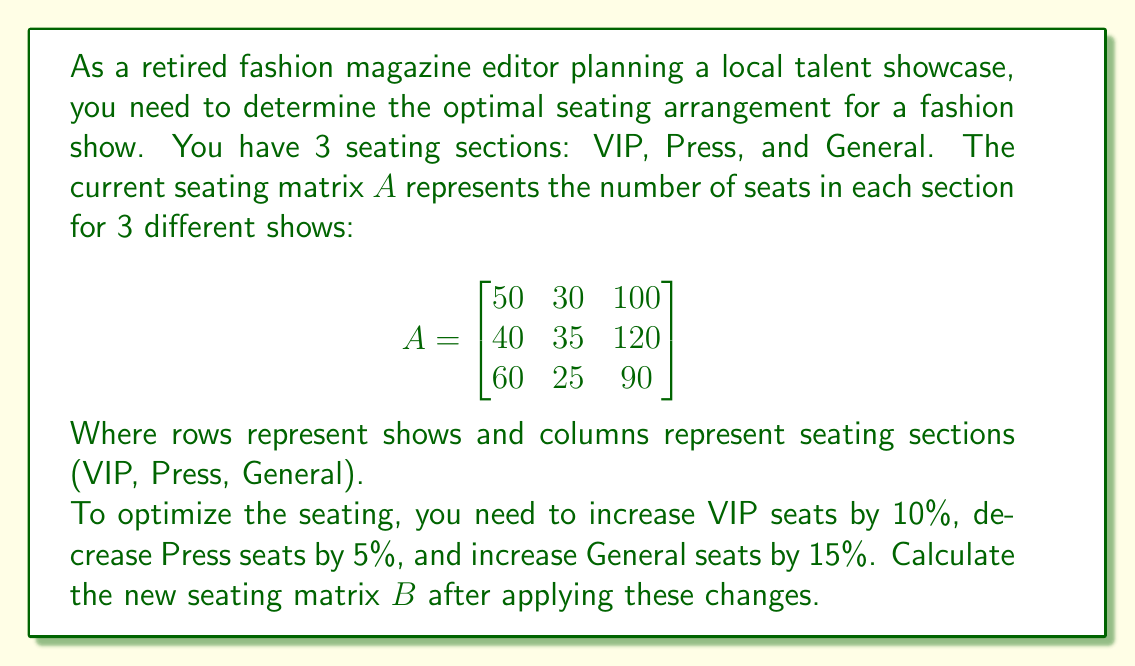Solve this math problem. To solve this problem, we need to apply the given percentage changes to each section of seats across all shows. We can do this by multiplying the original matrix $A$ with a diagonal matrix containing the scaling factors.

Step 1: Create the scaling matrix
VIP seats increase by 10%: 1.10
Press seats decrease by 5%: 0.95
General seats increase by 15%: 1.15

The scaling matrix $S$ is:

$$S = \begin{bmatrix}
1.10 & 0 & 0 \\
0 & 0.95 & 0 \\
0 & 0 & 1.15
\end{bmatrix}$$

Step 2: Multiply matrix $A$ by matrix $S$

$$B = A \times S$$

$$B = \begin{bmatrix}
50 & 30 & 100 \\
40 & 35 & 120 \\
60 & 25 & 90
\end{bmatrix} \times 
\begin{bmatrix}
1.10 & 0 & 0 \\
0 & 0.95 & 0 \\
0 & 0 & 1.15
\end{bmatrix}$$

Step 3: Perform the matrix multiplication

$$B = \begin{bmatrix}
50 \times 1.10 & 30 \times 0.95 & 100 \times 1.15 \\
40 \times 1.10 & 35 \times 0.95 & 120 \times 1.15 \\
60 \times 1.10 & 25 \times 0.95 & 90 \times 1.15
\end{bmatrix}$$

$$B = \begin{bmatrix}
55 & 28.5 & 115 \\
44 & 33.25 & 138 \\
66 & 23.75 & 103.5
\end{bmatrix}$$

The resulting matrix $B$ represents the new seating arrangement for each show after applying the required changes.
Answer: $$B = \begin{bmatrix}
55 & 28.5 & 115 \\
44 & 33.25 & 138 \\
66 & 23.75 & 103.5
\end{bmatrix}$$ 